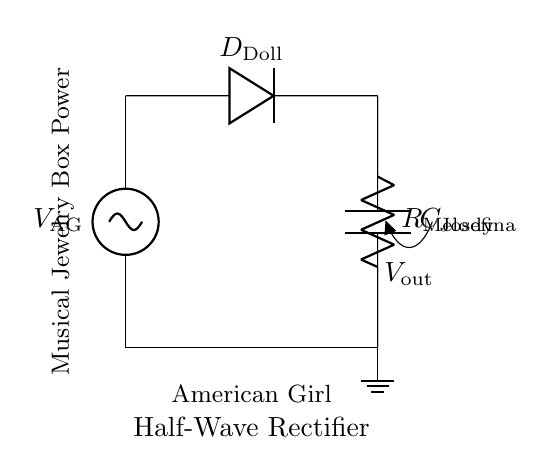What is the component type used for voltage regulation? The component used for voltage regulation in this circuit is the diode, labeled as D_doll. The diode allows current to flow in one direction, effectively converting the alternating current to direct current needed for the musical jewelry box.
Answer: diode What does R_Melody represent? R_Melody represents the resistor in the circuit. It is placed in series with the load, regulating the flow of current to ensure the connected components receive the appropriate power level without overloading.
Answer: resistor What is the output voltage labeled in the diagram? The output voltage in the circuit is labeled as V_out. This is the average voltage output after the rectification process, which is used by the musical jewelry box to function properly.
Answer: V_out Which component is responsible for smoothing the output voltage? The component responsible for smoothing the output voltage is the capacitor, labeled as C_Josefina. It stores charge and releases it gradually, helping to maintain a steady voltage level in the circuit.
Answer: capacitor What type of rectifier is this circuit? This circuit is a half-wave rectifier. It allows only one half of the input AC waveform to pass through, effectively converting AC to DC with reduced efficiency compared to full-wave rectifiers.
Answer: half-wave What is the purpose of the AC source labeled V_AG? The AC source labeled V_AG serves as the input voltage supplying alternating current to the circuit. This AC power is then rectified to provide direct current to the musical jewelry box's internal components.
Answer: input voltage How many active components are in this circuit? The circuit contains two active components: the diode (D_Doll) and the capacitor (C_Josefina). These components work together to convert AC to DC and smooth the output voltage for stable operation.
Answer: two 